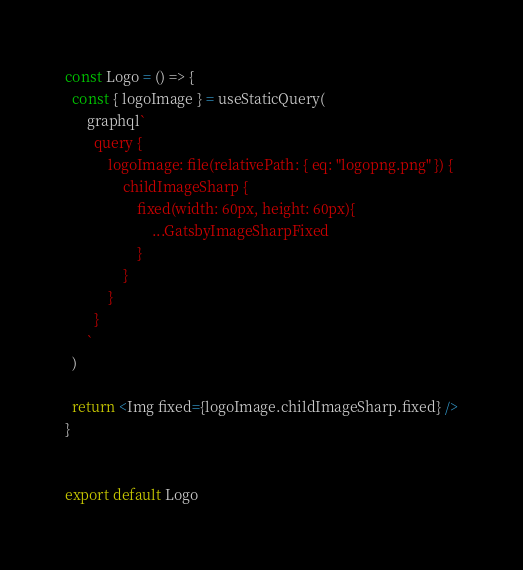<code> <loc_0><loc_0><loc_500><loc_500><_JavaScript_>
const Logo = () => {
  const { logoImage } = useStaticQuery(
      graphql`
        query {
            logoImage: file(relativePath: { eq: "logopng.png" }) {
                childImageSharp {
                    fixed(width: 60px, height: 60px){
                        ...GatsbyImageSharpFixed
                    }
                }
            }
        }
      `
  )

  return <Img fixed={logoImage.childImageSharp.fixed} />
}


export default Logo</code> 